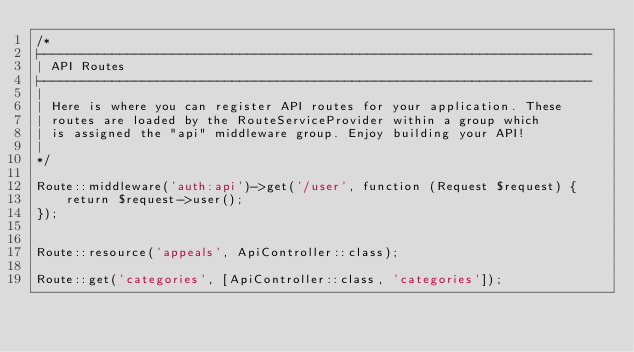<code> <loc_0><loc_0><loc_500><loc_500><_PHP_>/*
|--------------------------------------------------------------------------
| API Routes
|--------------------------------------------------------------------------
|
| Here is where you can register API routes for your application. These
| routes are loaded by the RouteServiceProvider within a group which
| is assigned the "api" middleware group. Enjoy building your API!
|
*/

Route::middleware('auth:api')->get('/user', function (Request $request) {
    return $request->user();
});


Route::resource('appeals', ApiController::class);

Route::get('categories', [ApiController::class, 'categories']);</code> 